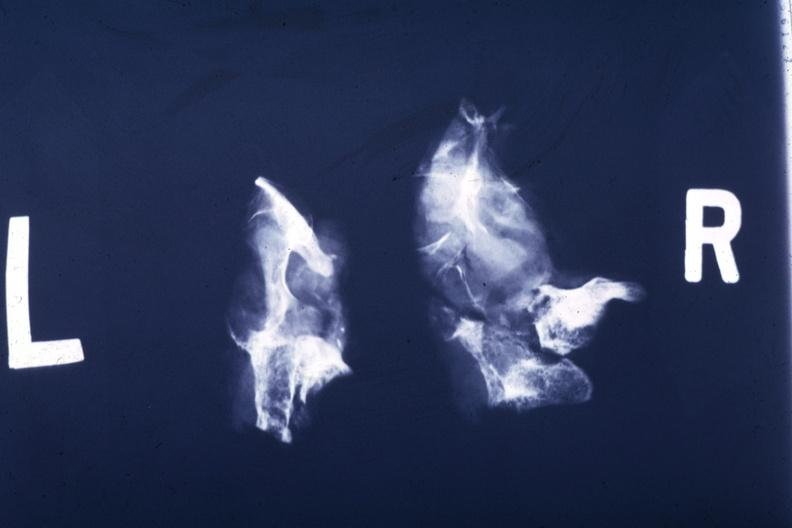what is present?
Answer the question using a single word or phrase. Malignant adenoma 